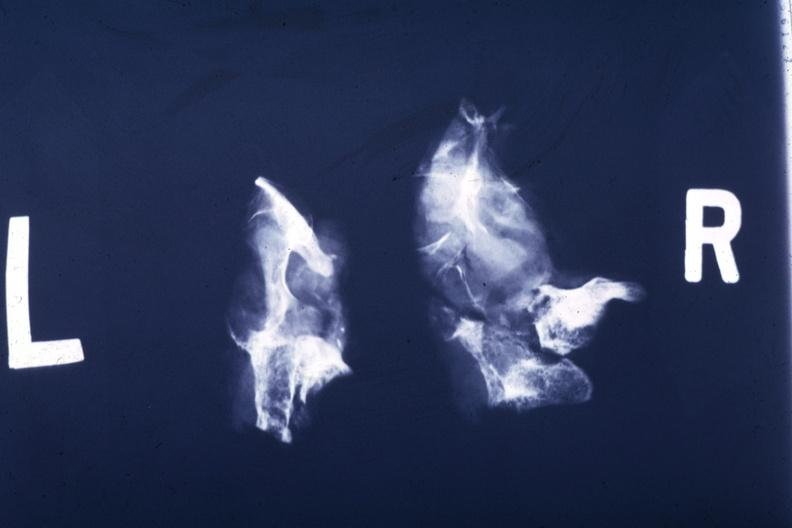what is present?
Answer the question using a single word or phrase. Malignant adenoma 